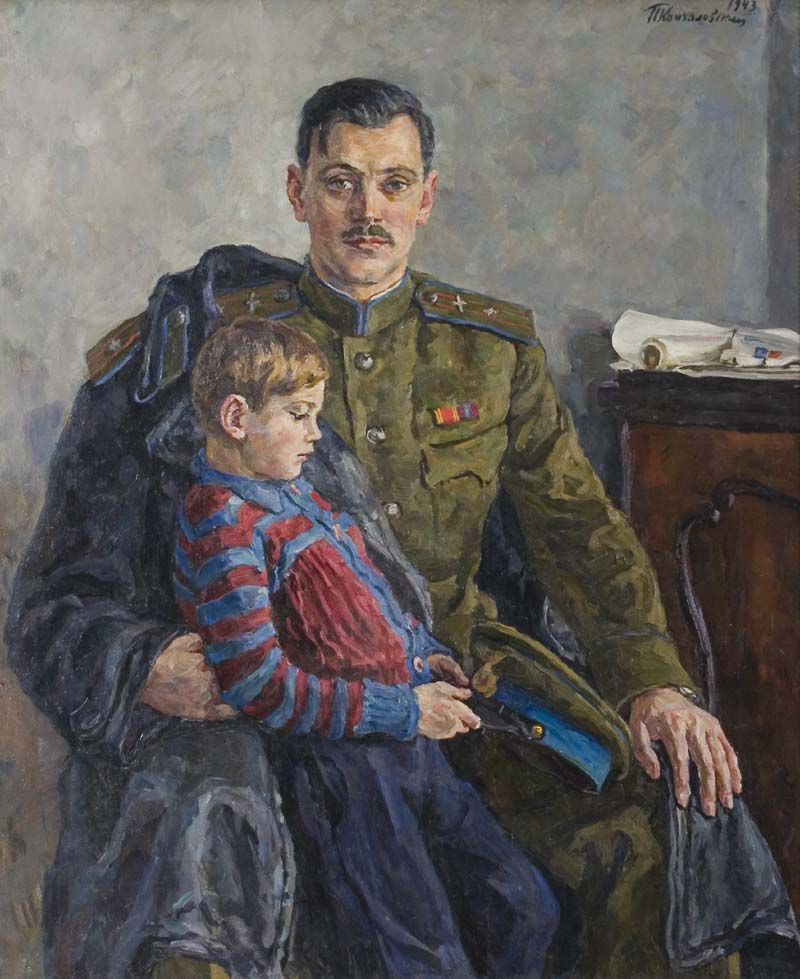Describe a possible story where the boy in the painting becomes a renowned artist. The boy on his father's lap grew up inspired by the innate warmth and solid presence his father provided. As he matured, he found solace and expression in the world of art. His early years were filled with sketches of his father, the military uniform, and scenes from his childhood. Over time, these sketches evolved into complex paintings capturing the raw emotions and stories of people. Achieving recognition for his unique ability to combine realism with emotional depth, he often credited his father for providing the emotional stability and rich life experiences that fueled his creativity. One of his most renowned exhibitions featured a series titled 'Reflections of Duty,' where he painted various scenes inspired by his father's life and their moments together, resonating deeply with audiences worldwide. What might the boy think about if he has a vivid dream about this moment in the painting reflecting his current adult worries? In a vivid dream, the boy—now an adult—sees himself once more on his father's lap. This scene taps into his current concerns and responsibilities. The boy might view himself retreating to the safety and simplicity of his childhood, seeking comfort from adult pressures. The dream could bring a warm, nostalgic refuge amidst his worries, reflecting fears of whether he can measure up to the lessons his father imparted or the looming responsibilities he faces, both of which he sees as heavier in the dream world. Waking from it, he understands the cyclical nature of duty, love, and the care essential across generations. 